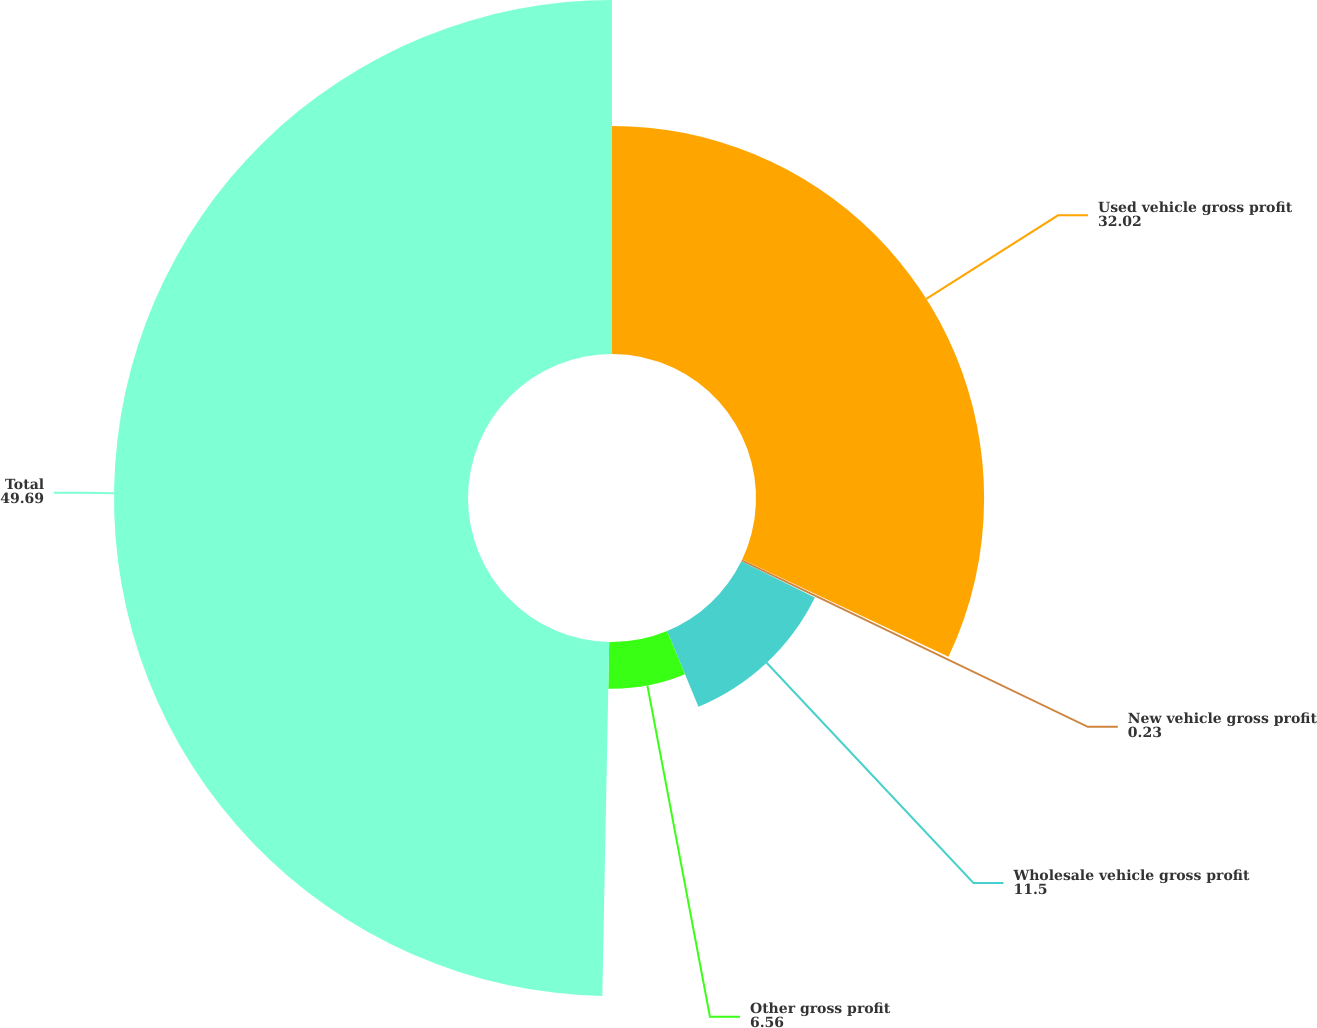Convert chart to OTSL. <chart><loc_0><loc_0><loc_500><loc_500><pie_chart><fcel>Used vehicle gross profit<fcel>New vehicle gross profit<fcel>Wholesale vehicle gross profit<fcel>Other gross profit<fcel>Total<nl><fcel>32.02%<fcel>0.23%<fcel>11.5%<fcel>6.56%<fcel>49.69%<nl></chart> 